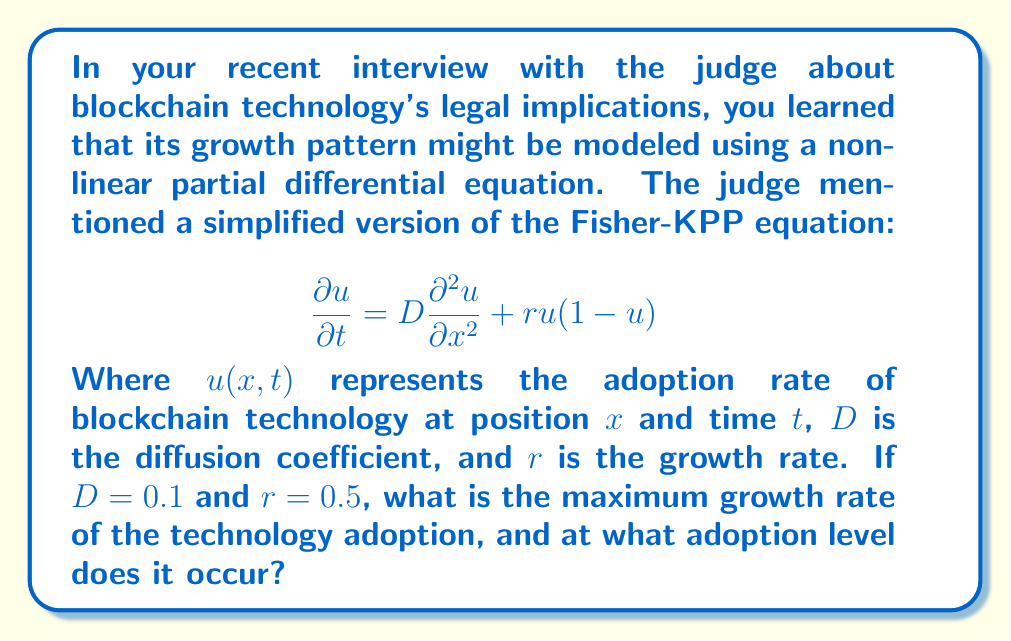What is the answer to this math problem? To solve this problem, we need to follow these steps:

1) The growth rate of the technology adoption is represented by the right-hand side of the equation:

   $$\frac{\partial u}{\partial t} = D\frac{\partial^2 u}{\partial x^2} + ru(1-u)$$

2) The maximum growth rate will occur when the spatial diffusion term $D\frac{\partial^2 u}{\partial x^2}$ is zero (assuming uniform adoption across space). So we focus on the term $ru(1-u)$.

3) Let's call this growth function $g(u) = ru(1-u)$.

4) To find the maximum of this function, we differentiate it with respect to u and set it to zero:

   $$\frac{dg}{du} = r(1-u) - ru = r(1-2u)$$

   Set this equal to zero:
   $$r(1-2u) = 0$$

5) Solving this equation:
   $$1-2u = 0$$
   $$2u = 1$$
   $$u = \frac{1}{2}$$

6) This means the maximum growth rate occurs when the adoption rate is 50%.

7) To find the value of the maximum growth rate, we substitute $u = \frac{1}{2}$ back into $g(u)$:

   $$g(\frac{1}{2}) = r(\frac{1}{2})(1-\frac{1}{2}) = \frac{r}{4}$$

8) Given $r = 0.5$, the maximum growth rate is:

   $$\frac{0.5}{4} = 0.125$$

Therefore, the maximum growth rate is 0.125, occurring when the adoption rate is 50%.
Answer: The maximum growth rate is 0.125, occurring when the blockchain technology adoption rate is 50%. 